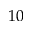<formula> <loc_0><loc_0><loc_500><loc_500>1 0</formula> 